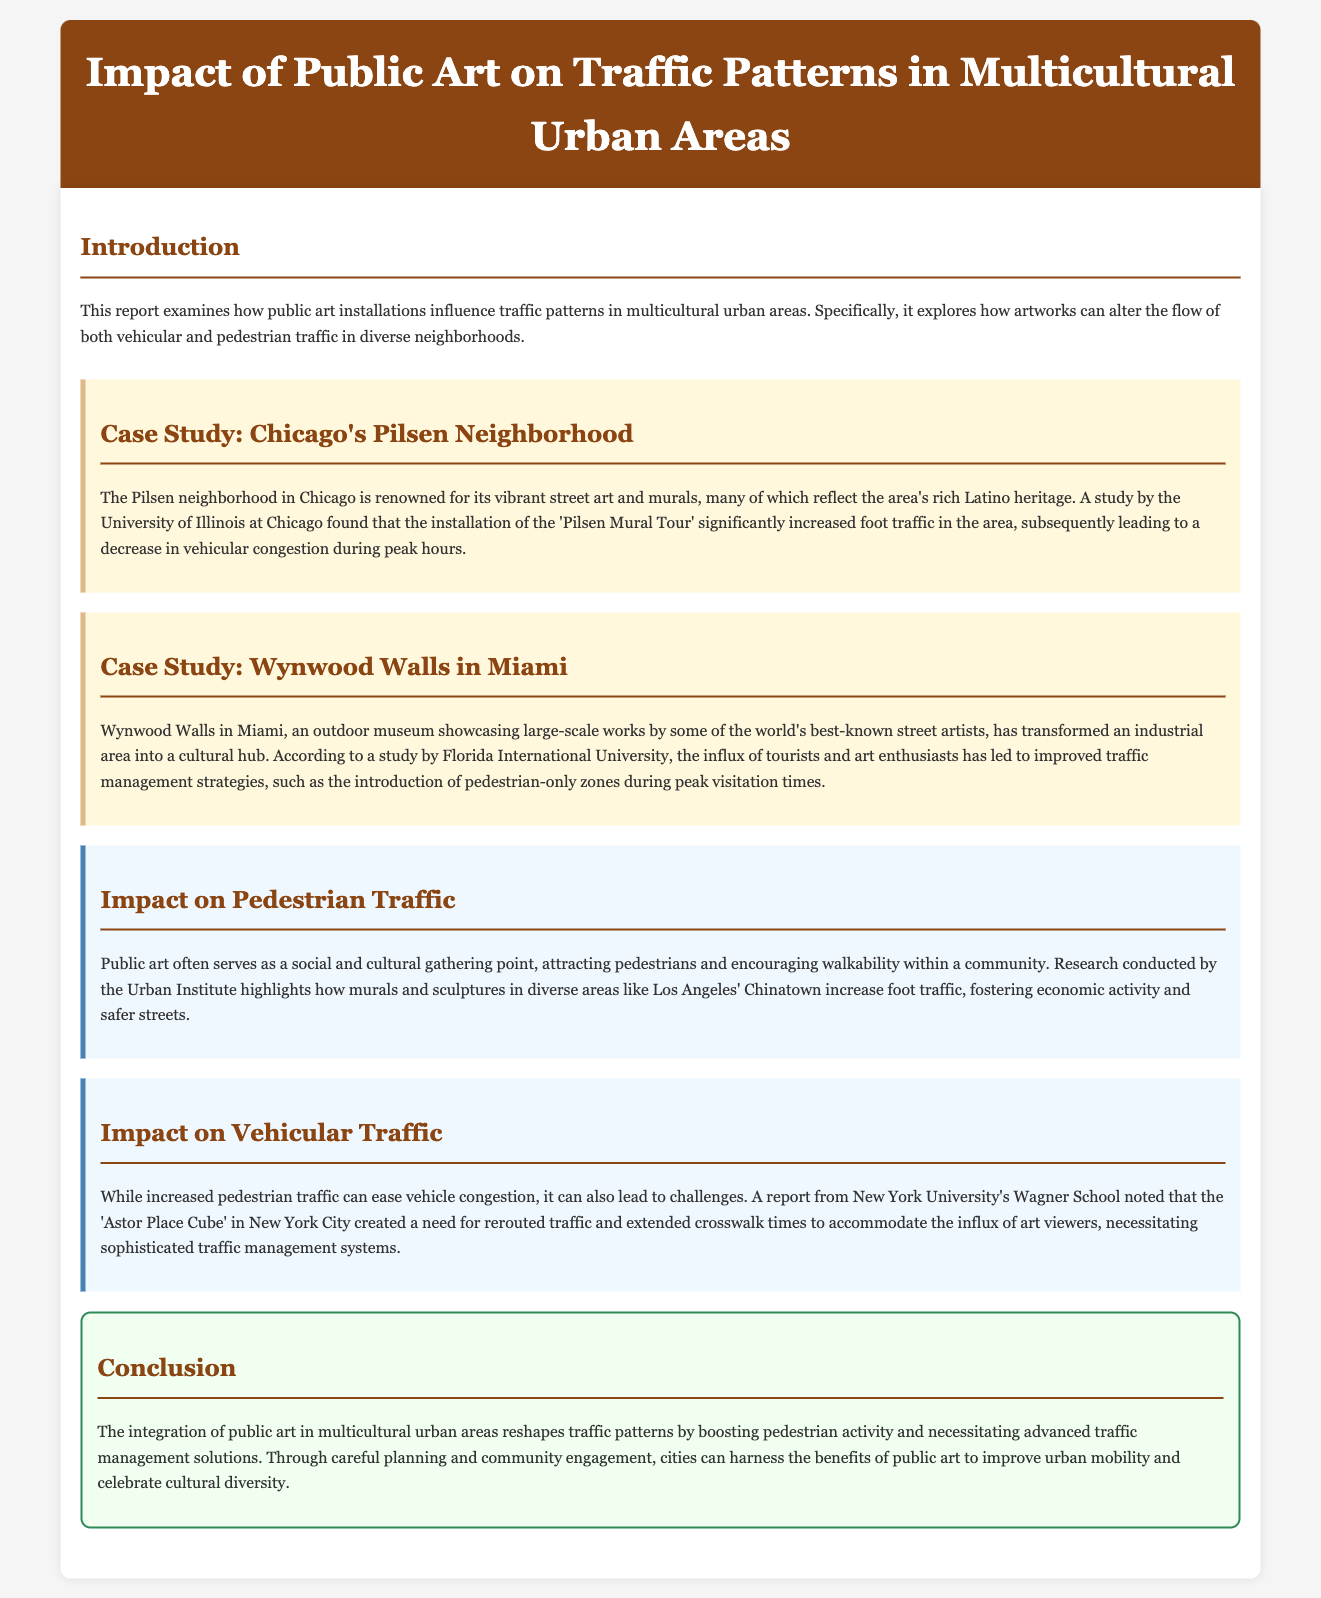What is the focus of the report? The report examines how public art installations influence traffic patterns in multicultural urban areas.
Answer: Influence of public art on traffic patterns What case study is mentioned for Chicago? The piece discusses a specific case study that highlights the effects of public art in a Chicago neighborhood.
Answer: Pilsen Neighborhood Which university conducted a study about the Pilsen Mural Tour? The study mentioned regarding the impact of the Pilsen Mural Tour was conducted by a specific university.
Answer: University of Illinois at Chicago What cultural aspect does Miami's Wynwood Walls represent? The report describes the transformation of an industrial area into a cultural hub through public art.
Answer: Cultural hub According to the Urban Institute, what do murals and sculptures increase in diverse areas? The document cites research findings that reveal the impact of public art on community dynamics.
Answer: Foot traffic What challenge arose from the Astor Place Cube in New York City? A specific traffic management issue is noted in relation to the influx of visitors due to public art.
Answer: Rerouted traffic What was one of the benefits of increased pedestrian traffic? The document specifies a positive outcome related to pedestrian activity fostered by public art.
Answer: Economic activity What is essential for cities to harness the benefits of public art? The conclusion emphasizes the importance of a specific strategy in relation to public art integration.
Answer: Planning and community engagement 